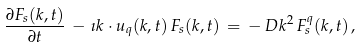Convert formula to latex. <formula><loc_0><loc_0><loc_500><loc_500>\frac { \partial { F _ { s } ( k , t ) } } { \partial { t } } \, - \, \imath k \cdot u _ { q } ( k , t ) \, { F _ { s } ( k , t ) } \, = \, - \, D k ^ { 2 } \, { F _ { s } ^ { q } ( k , t ) } \, ,</formula> 